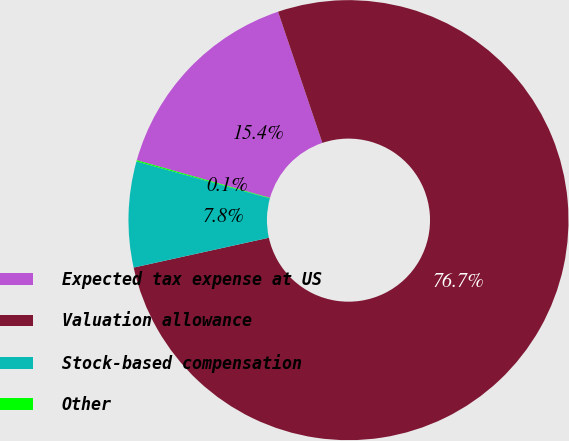Convert chart to OTSL. <chart><loc_0><loc_0><loc_500><loc_500><pie_chart><fcel>Expected tax expense at US<fcel>Valuation allowance<fcel>Stock-based compensation<fcel>Other<nl><fcel>15.42%<fcel>76.73%<fcel>7.76%<fcel>0.09%<nl></chart> 